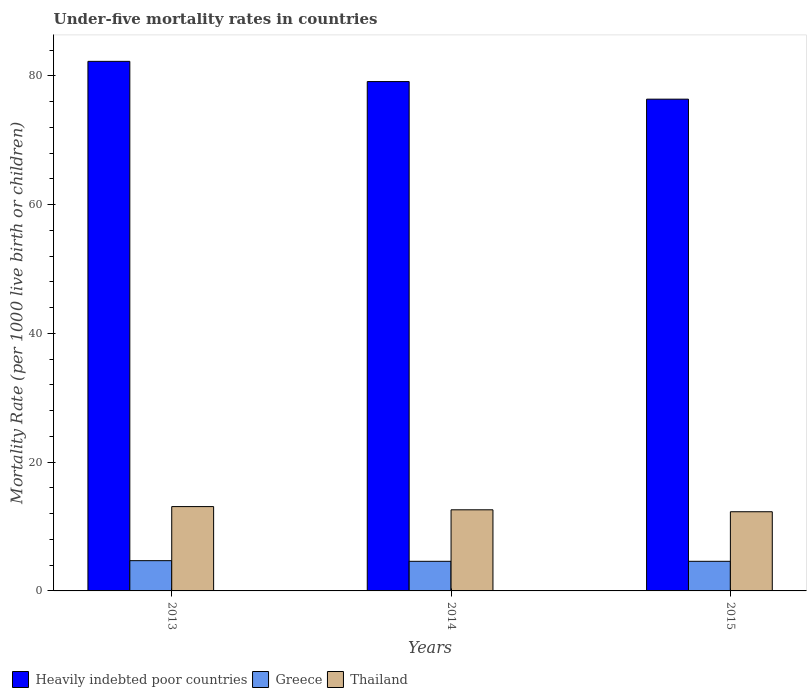How many different coloured bars are there?
Provide a succinct answer. 3. How many bars are there on the 1st tick from the left?
Ensure brevity in your answer.  3. What is the label of the 2nd group of bars from the left?
Keep it short and to the point. 2014. What is the under-five mortality rate in Thailand in 2014?
Provide a short and direct response. 12.6. In which year was the under-five mortality rate in Heavily indebted poor countries maximum?
Your answer should be compact. 2013. In which year was the under-five mortality rate in Heavily indebted poor countries minimum?
Your answer should be very brief. 2015. What is the total under-five mortality rate in Greece in the graph?
Provide a succinct answer. 13.9. What is the difference between the under-five mortality rate in Heavily indebted poor countries in 2014 and that in 2015?
Your answer should be compact. 2.73. What is the difference between the under-five mortality rate in Heavily indebted poor countries in 2015 and the under-five mortality rate in Greece in 2013?
Your answer should be very brief. 71.68. What is the average under-five mortality rate in Thailand per year?
Offer a terse response. 12.67. In the year 2015, what is the difference between the under-five mortality rate in Heavily indebted poor countries and under-five mortality rate in Greece?
Offer a terse response. 71.78. What is the ratio of the under-five mortality rate in Greece in 2013 to that in 2014?
Your answer should be compact. 1.02. Is the under-five mortality rate in Greece in 2014 less than that in 2015?
Offer a very short reply. No. Is the difference between the under-five mortality rate in Heavily indebted poor countries in 2013 and 2014 greater than the difference between the under-five mortality rate in Greece in 2013 and 2014?
Make the answer very short. Yes. What is the difference between the highest and the second highest under-five mortality rate in Greece?
Your response must be concise. 0.1. What is the difference between the highest and the lowest under-five mortality rate in Heavily indebted poor countries?
Offer a terse response. 5.87. Is the sum of the under-five mortality rate in Greece in 2013 and 2015 greater than the maximum under-five mortality rate in Heavily indebted poor countries across all years?
Give a very brief answer. No. What does the 3rd bar from the left in 2015 represents?
Make the answer very short. Thailand. What does the 2nd bar from the right in 2014 represents?
Your response must be concise. Greece. Is it the case that in every year, the sum of the under-five mortality rate in Heavily indebted poor countries and under-five mortality rate in Thailand is greater than the under-five mortality rate in Greece?
Keep it short and to the point. Yes. How many bars are there?
Offer a terse response. 9. Are all the bars in the graph horizontal?
Offer a terse response. No. How many years are there in the graph?
Provide a short and direct response. 3. What is the difference between two consecutive major ticks on the Y-axis?
Offer a very short reply. 20. Does the graph contain grids?
Provide a short and direct response. No. Where does the legend appear in the graph?
Give a very brief answer. Bottom left. What is the title of the graph?
Your response must be concise. Under-five mortality rates in countries. What is the label or title of the Y-axis?
Your response must be concise. Mortality Rate (per 1000 live birth or children). What is the Mortality Rate (per 1000 live birth or children) in Heavily indebted poor countries in 2013?
Your answer should be compact. 82.26. What is the Mortality Rate (per 1000 live birth or children) of Greece in 2013?
Your response must be concise. 4.7. What is the Mortality Rate (per 1000 live birth or children) of Thailand in 2013?
Provide a short and direct response. 13.1. What is the Mortality Rate (per 1000 live birth or children) of Heavily indebted poor countries in 2014?
Offer a very short reply. 79.12. What is the Mortality Rate (per 1000 live birth or children) of Heavily indebted poor countries in 2015?
Give a very brief answer. 76.38. Across all years, what is the maximum Mortality Rate (per 1000 live birth or children) in Heavily indebted poor countries?
Offer a terse response. 82.26. Across all years, what is the maximum Mortality Rate (per 1000 live birth or children) in Greece?
Your answer should be very brief. 4.7. Across all years, what is the minimum Mortality Rate (per 1000 live birth or children) in Heavily indebted poor countries?
Offer a terse response. 76.38. Across all years, what is the minimum Mortality Rate (per 1000 live birth or children) of Greece?
Offer a terse response. 4.6. Across all years, what is the minimum Mortality Rate (per 1000 live birth or children) of Thailand?
Keep it short and to the point. 12.3. What is the total Mortality Rate (per 1000 live birth or children) in Heavily indebted poor countries in the graph?
Your answer should be very brief. 237.76. What is the total Mortality Rate (per 1000 live birth or children) of Thailand in the graph?
Offer a very short reply. 38. What is the difference between the Mortality Rate (per 1000 live birth or children) of Heavily indebted poor countries in 2013 and that in 2014?
Keep it short and to the point. 3.14. What is the difference between the Mortality Rate (per 1000 live birth or children) in Greece in 2013 and that in 2014?
Your answer should be compact. 0.1. What is the difference between the Mortality Rate (per 1000 live birth or children) of Thailand in 2013 and that in 2014?
Offer a very short reply. 0.5. What is the difference between the Mortality Rate (per 1000 live birth or children) in Heavily indebted poor countries in 2013 and that in 2015?
Offer a very short reply. 5.87. What is the difference between the Mortality Rate (per 1000 live birth or children) of Heavily indebted poor countries in 2014 and that in 2015?
Provide a succinct answer. 2.73. What is the difference between the Mortality Rate (per 1000 live birth or children) of Greece in 2014 and that in 2015?
Ensure brevity in your answer.  0. What is the difference between the Mortality Rate (per 1000 live birth or children) in Heavily indebted poor countries in 2013 and the Mortality Rate (per 1000 live birth or children) in Greece in 2014?
Keep it short and to the point. 77.66. What is the difference between the Mortality Rate (per 1000 live birth or children) in Heavily indebted poor countries in 2013 and the Mortality Rate (per 1000 live birth or children) in Thailand in 2014?
Offer a terse response. 69.66. What is the difference between the Mortality Rate (per 1000 live birth or children) of Greece in 2013 and the Mortality Rate (per 1000 live birth or children) of Thailand in 2014?
Your answer should be very brief. -7.9. What is the difference between the Mortality Rate (per 1000 live birth or children) of Heavily indebted poor countries in 2013 and the Mortality Rate (per 1000 live birth or children) of Greece in 2015?
Provide a short and direct response. 77.66. What is the difference between the Mortality Rate (per 1000 live birth or children) of Heavily indebted poor countries in 2013 and the Mortality Rate (per 1000 live birth or children) of Thailand in 2015?
Ensure brevity in your answer.  69.96. What is the difference between the Mortality Rate (per 1000 live birth or children) in Heavily indebted poor countries in 2014 and the Mortality Rate (per 1000 live birth or children) in Greece in 2015?
Give a very brief answer. 74.52. What is the difference between the Mortality Rate (per 1000 live birth or children) of Heavily indebted poor countries in 2014 and the Mortality Rate (per 1000 live birth or children) of Thailand in 2015?
Your answer should be very brief. 66.82. What is the difference between the Mortality Rate (per 1000 live birth or children) in Greece in 2014 and the Mortality Rate (per 1000 live birth or children) in Thailand in 2015?
Provide a short and direct response. -7.7. What is the average Mortality Rate (per 1000 live birth or children) in Heavily indebted poor countries per year?
Provide a short and direct response. 79.25. What is the average Mortality Rate (per 1000 live birth or children) in Greece per year?
Your answer should be compact. 4.63. What is the average Mortality Rate (per 1000 live birth or children) in Thailand per year?
Your answer should be very brief. 12.67. In the year 2013, what is the difference between the Mortality Rate (per 1000 live birth or children) in Heavily indebted poor countries and Mortality Rate (per 1000 live birth or children) in Greece?
Offer a very short reply. 77.56. In the year 2013, what is the difference between the Mortality Rate (per 1000 live birth or children) in Heavily indebted poor countries and Mortality Rate (per 1000 live birth or children) in Thailand?
Offer a very short reply. 69.16. In the year 2013, what is the difference between the Mortality Rate (per 1000 live birth or children) of Greece and Mortality Rate (per 1000 live birth or children) of Thailand?
Provide a short and direct response. -8.4. In the year 2014, what is the difference between the Mortality Rate (per 1000 live birth or children) of Heavily indebted poor countries and Mortality Rate (per 1000 live birth or children) of Greece?
Give a very brief answer. 74.52. In the year 2014, what is the difference between the Mortality Rate (per 1000 live birth or children) of Heavily indebted poor countries and Mortality Rate (per 1000 live birth or children) of Thailand?
Give a very brief answer. 66.52. In the year 2014, what is the difference between the Mortality Rate (per 1000 live birth or children) in Greece and Mortality Rate (per 1000 live birth or children) in Thailand?
Make the answer very short. -8. In the year 2015, what is the difference between the Mortality Rate (per 1000 live birth or children) of Heavily indebted poor countries and Mortality Rate (per 1000 live birth or children) of Greece?
Give a very brief answer. 71.78. In the year 2015, what is the difference between the Mortality Rate (per 1000 live birth or children) of Heavily indebted poor countries and Mortality Rate (per 1000 live birth or children) of Thailand?
Offer a very short reply. 64.08. In the year 2015, what is the difference between the Mortality Rate (per 1000 live birth or children) in Greece and Mortality Rate (per 1000 live birth or children) in Thailand?
Your answer should be compact. -7.7. What is the ratio of the Mortality Rate (per 1000 live birth or children) of Heavily indebted poor countries in 2013 to that in 2014?
Your response must be concise. 1.04. What is the ratio of the Mortality Rate (per 1000 live birth or children) of Greece in 2013 to that in 2014?
Your answer should be very brief. 1.02. What is the ratio of the Mortality Rate (per 1000 live birth or children) in Thailand in 2013 to that in 2014?
Provide a succinct answer. 1.04. What is the ratio of the Mortality Rate (per 1000 live birth or children) in Greece in 2013 to that in 2015?
Provide a short and direct response. 1.02. What is the ratio of the Mortality Rate (per 1000 live birth or children) of Thailand in 2013 to that in 2015?
Provide a short and direct response. 1.06. What is the ratio of the Mortality Rate (per 1000 live birth or children) of Heavily indebted poor countries in 2014 to that in 2015?
Your answer should be compact. 1.04. What is the ratio of the Mortality Rate (per 1000 live birth or children) in Greece in 2014 to that in 2015?
Provide a short and direct response. 1. What is the ratio of the Mortality Rate (per 1000 live birth or children) of Thailand in 2014 to that in 2015?
Your response must be concise. 1.02. What is the difference between the highest and the second highest Mortality Rate (per 1000 live birth or children) in Heavily indebted poor countries?
Give a very brief answer. 3.14. What is the difference between the highest and the second highest Mortality Rate (per 1000 live birth or children) of Greece?
Provide a short and direct response. 0.1. What is the difference between the highest and the lowest Mortality Rate (per 1000 live birth or children) of Heavily indebted poor countries?
Offer a very short reply. 5.87. What is the difference between the highest and the lowest Mortality Rate (per 1000 live birth or children) of Thailand?
Keep it short and to the point. 0.8. 